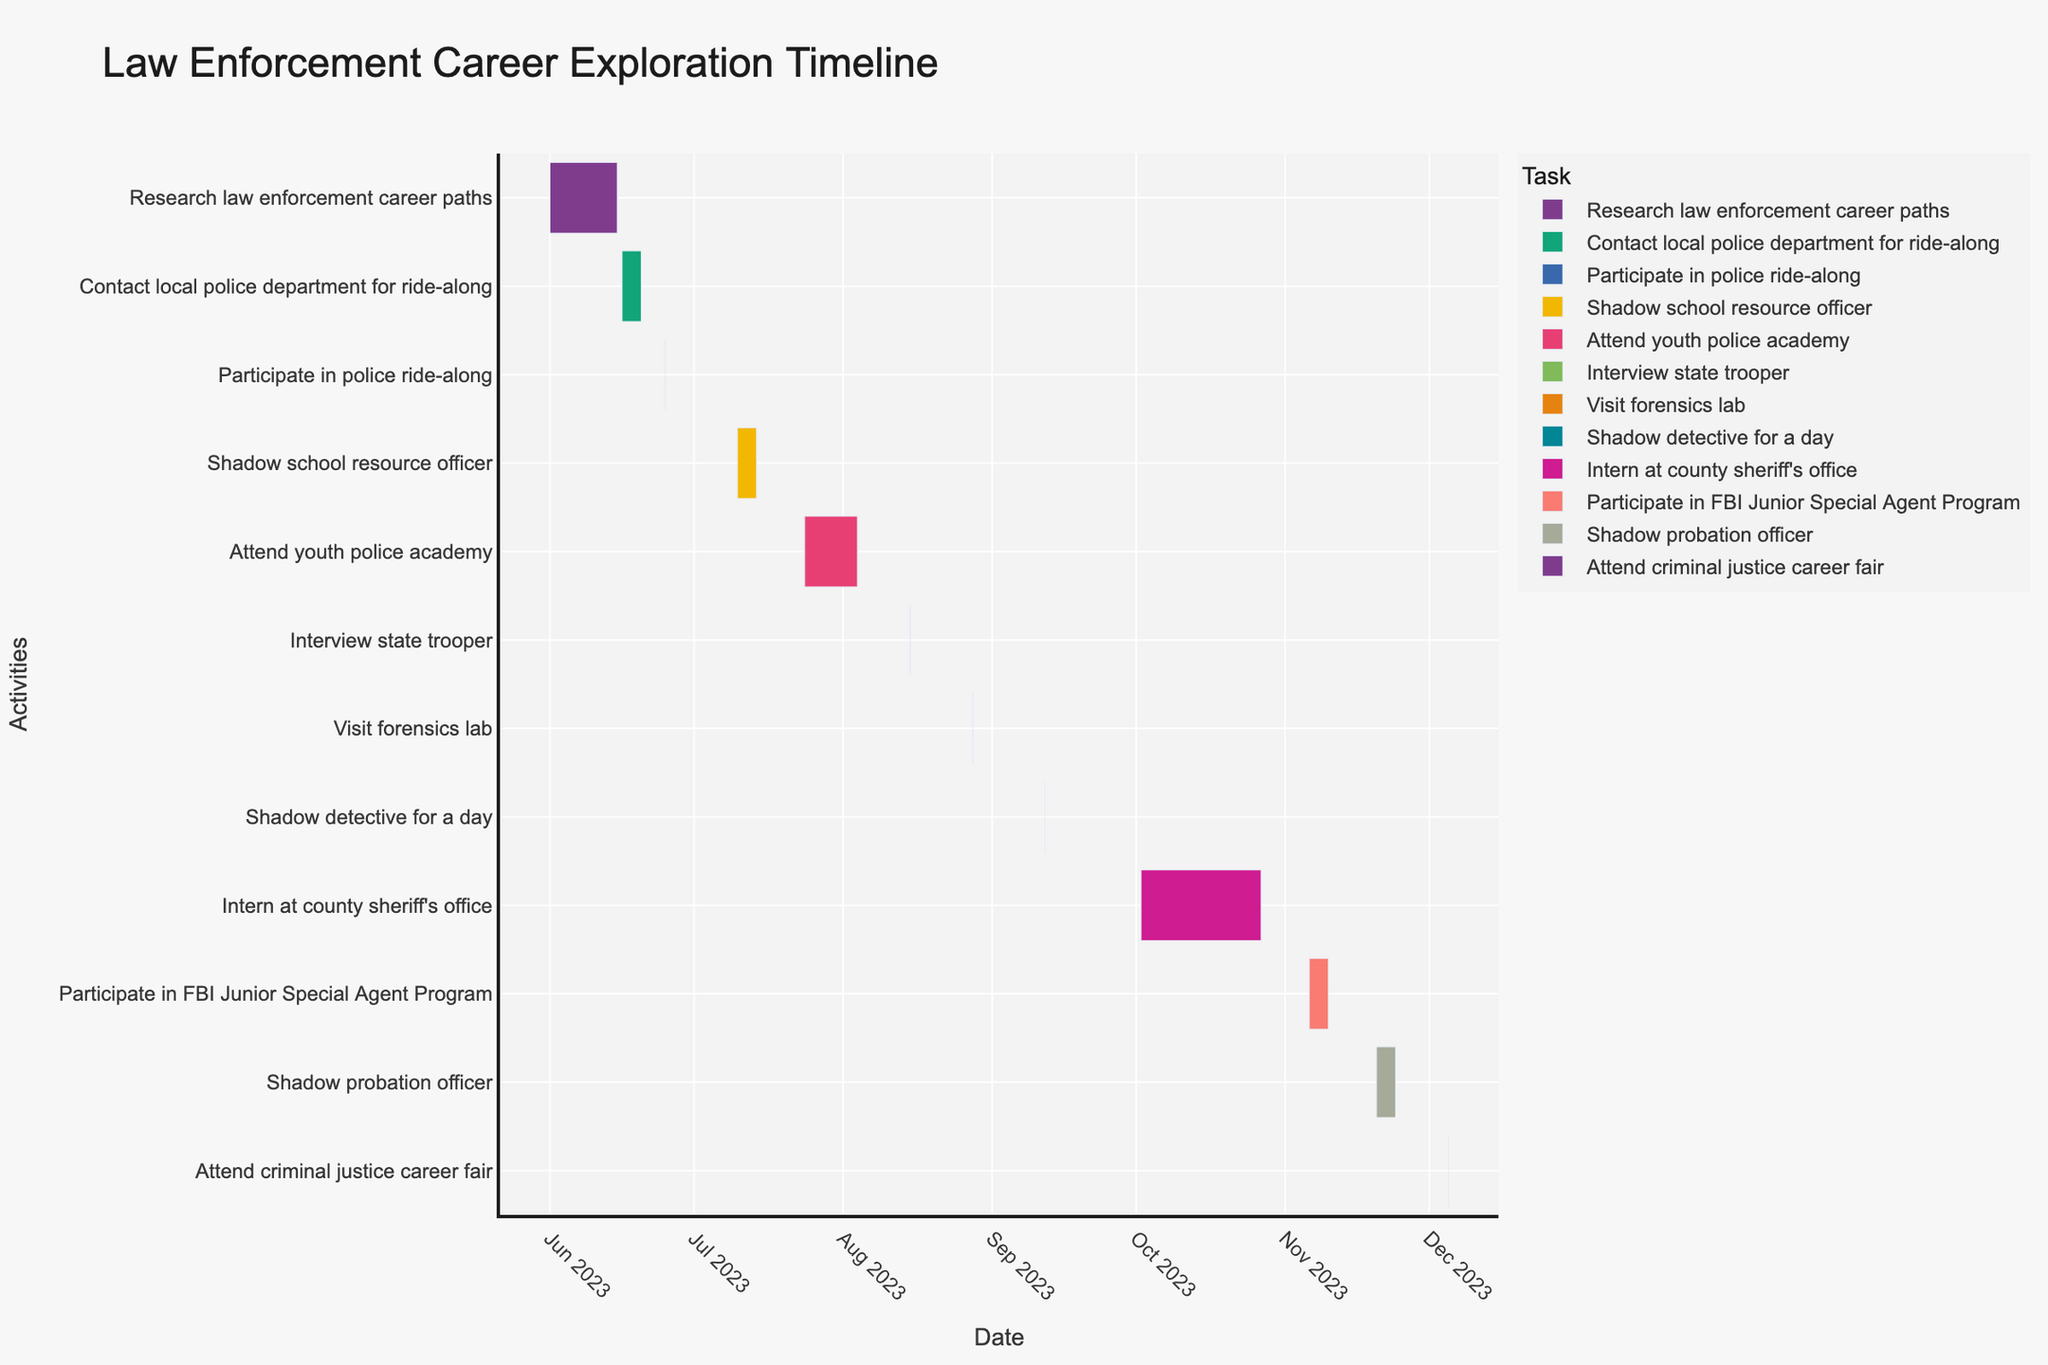What's the title of the Gantt chart? The title is usually displayed at the top of a chart in larger, bold text.
Answer: Law Enforcement Career Exploration Timeline Which task has the longest duration? By looking at the bars representing each task, the longest one extends the farthest along the x-axis.
Answer: Internship at county sheriff's office Which event takes place on August 15th? Identify the date on the x-axis and find the corresponding task bar that aligns with it.
Answer: Interview state trooper How many tasks are scheduled in July? Count the number of task bars that have start or end dates within the month of July.
Answer: 2 How long is the youth police academy event? Calculate the duration by subtracting the start date from the end date and adding 1 day.
Answer: 12 days Which tasks are scheduled after October? Look at the tasks scheduled in November and December based on their start dates.
Answer: Participate in FBI Junior Special Agent Program, Shadow probation officer, Attend criminal justice career fair What is the total duration of all tasks combined in June? Sum the durations of all tasks starting and ending in June.
Answer: 20 days Which tasks last only one day? Identify the tasks where the start and end dates are the same.
Answer: Participate in police ride-along, Interview state trooper, Visit forensics lab, Shadow detective for a day, Attend criminal justice career fair How many days are there between the end of shadowing the school resource officer and the start of the youth police academy? Find the end date of the first task and the start date of the second task, then calculate the difference.
Answer: 10 days Are there any overlapping tasks, and if so, which ones? Look for any tasks that have overlapping date ranges on the timeline.
Answer: No overlapping tasks 